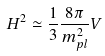<formula> <loc_0><loc_0><loc_500><loc_500>H ^ { 2 } \simeq \frac { 1 } { 3 } \frac { 8 \pi } { m _ { p l } ^ { 2 } } V</formula> 